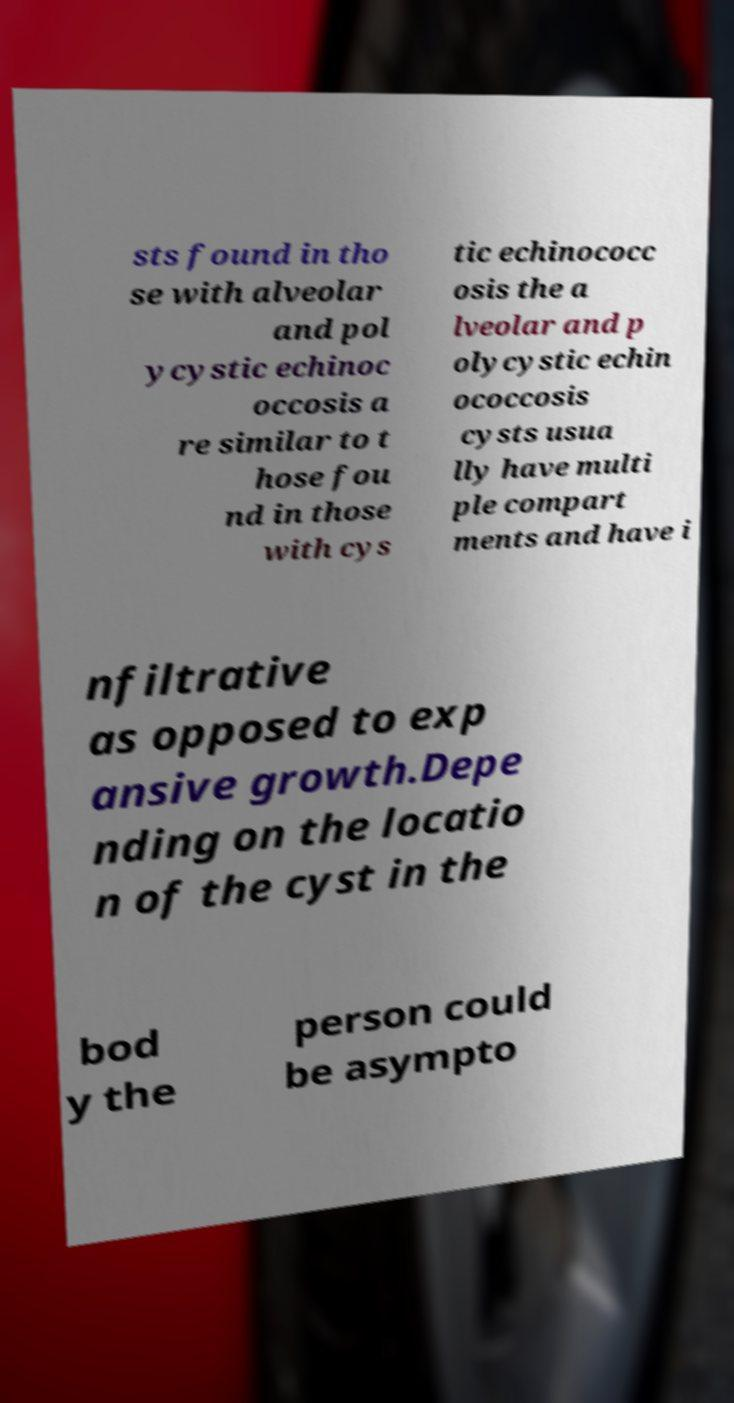What messages or text are displayed in this image? I need them in a readable, typed format. sts found in tho se with alveolar and pol ycystic echinoc occosis a re similar to t hose fou nd in those with cys tic echinococc osis the a lveolar and p olycystic echin ococcosis cysts usua lly have multi ple compart ments and have i nfiltrative as opposed to exp ansive growth.Depe nding on the locatio n of the cyst in the bod y the person could be asympto 